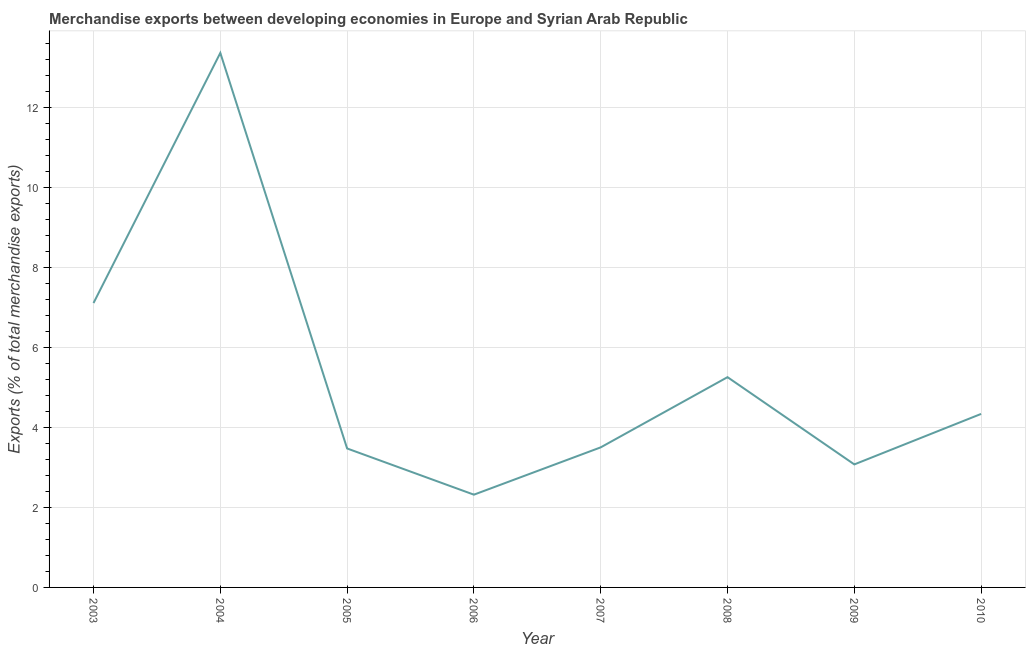What is the merchandise exports in 2007?
Your answer should be very brief. 3.5. Across all years, what is the maximum merchandise exports?
Make the answer very short. 13.37. Across all years, what is the minimum merchandise exports?
Make the answer very short. 2.32. In which year was the merchandise exports maximum?
Ensure brevity in your answer.  2004. In which year was the merchandise exports minimum?
Your response must be concise. 2006. What is the sum of the merchandise exports?
Your answer should be compact. 42.46. What is the difference between the merchandise exports in 2003 and 2008?
Provide a short and direct response. 1.85. What is the average merchandise exports per year?
Provide a short and direct response. 5.31. What is the median merchandise exports?
Offer a terse response. 3.92. Do a majority of the years between 2009 and 2008 (inclusive) have merchandise exports greater than 2 %?
Make the answer very short. No. What is the ratio of the merchandise exports in 2003 to that in 2004?
Make the answer very short. 0.53. Is the merchandise exports in 2003 less than that in 2005?
Ensure brevity in your answer.  No. What is the difference between the highest and the second highest merchandise exports?
Give a very brief answer. 6.26. What is the difference between the highest and the lowest merchandise exports?
Keep it short and to the point. 11.05. In how many years, is the merchandise exports greater than the average merchandise exports taken over all years?
Your response must be concise. 2. Does the merchandise exports monotonically increase over the years?
Make the answer very short. No. How many lines are there?
Make the answer very short. 1. What is the difference between two consecutive major ticks on the Y-axis?
Make the answer very short. 2. Are the values on the major ticks of Y-axis written in scientific E-notation?
Ensure brevity in your answer.  No. Does the graph contain any zero values?
Make the answer very short. No. What is the title of the graph?
Make the answer very short. Merchandise exports between developing economies in Europe and Syrian Arab Republic. What is the label or title of the X-axis?
Your answer should be compact. Year. What is the label or title of the Y-axis?
Your response must be concise. Exports (% of total merchandise exports). What is the Exports (% of total merchandise exports) in 2003?
Your answer should be compact. 7.11. What is the Exports (% of total merchandise exports) of 2004?
Ensure brevity in your answer.  13.37. What is the Exports (% of total merchandise exports) in 2005?
Offer a terse response. 3.48. What is the Exports (% of total merchandise exports) of 2006?
Your response must be concise. 2.32. What is the Exports (% of total merchandise exports) of 2007?
Offer a terse response. 3.5. What is the Exports (% of total merchandise exports) in 2008?
Provide a succinct answer. 5.26. What is the Exports (% of total merchandise exports) in 2009?
Your answer should be very brief. 3.08. What is the Exports (% of total merchandise exports) of 2010?
Your response must be concise. 4.34. What is the difference between the Exports (% of total merchandise exports) in 2003 and 2004?
Your answer should be compact. -6.26. What is the difference between the Exports (% of total merchandise exports) in 2003 and 2005?
Provide a succinct answer. 3.64. What is the difference between the Exports (% of total merchandise exports) in 2003 and 2006?
Your response must be concise. 4.79. What is the difference between the Exports (% of total merchandise exports) in 2003 and 2007?
Provide a succinct answer. 3.61. What is the difference between the Exports (% of total merchandise exports) in 2003 and 2008?
Your answer should be compact. 1.85. What is the difference between the Exports (% of total merchandise exports) in 2003 and 2009?
Provide a short and direct response. 4.04. What is the difference between the Exports (% of total merchandise exports) in 2003 and 2010?
Give a very brief answer. 2.77. What is the difference between the Exports (% of total merchandise exports) in 2004 and 2005?
Offer a terse response. 9.89. What is the difference between the Exports (% of total merchandise exports) in 2004 and 2006?
Offer a terse response. 11.05. What is the difference between the Exports (% of total merchandise exports) in 2004 and 2007?
Keep it short and to the point. 9.87. What is the difference between the Exports (% of total merchandise exports) in 2004 and 2008?
Ensure brevity in your answer.  8.11. What is the difference between the Exports (% of total merchandise exports) in 2004 and 2009?
Provide a succinct answer. 10.29. What is the difference between the Exports (% of total merchandise exports) in 2004 and 2010?
Make the answer very short. 9.03. What is the difference between the Exports (% of total merchandise exports) in 2005 and 2006?
Your answer should be very brief. 1.16. What is the difference between the Exports (% of total merchandise exports) in 2005 and 2007?
Offer a terse response. -0.03. What is the difference between the Exports (% of total merchandise exports) in 2005 and 2008?
Offer a very short reply. -1.78. What is the difference between the Exports (% of total merchandise exports) in 2005 and 2009?
Provide a succinct answer. 0.4. What is the difference between the Exports (% of total merchandise exports) in 2005 and 2010?
Give a very brief answer. -0.86. What is the difference between the Exports (% of total merchandise exports) in 2006 and 2007?
Your answer should be compact. -1.18. What is the difference between the Exports (% of total merchandise exports) in 2006 and 2008?
Offer a terse response. -2.94. What is the difference between the Exports (% of total merchandise exports) in 2006 and 2009?
Keep it short and to the point. -0.76. What is the difference between the Exports (% of total merchandise exports) in 2006 and 2010?
Make the answer very short. -2.02. What is the difference between the Exports (% of total merchandise exports) in 2007 and 2008?
Make the answer very short. -1.76. What is the difference between the Exports (% of total merchandise exports) in 2007 and 2009?
Your response must be concise. 0.43. What is the difference between the Exports (% of total merchandise exports) in 2007 and 2010?
Ensure brevity in your answer.  -0.84. What is the difference between the Exports (% of total merchandise exports) in 2008 and 2009?
Give a very brief answer. 2.18. What is the difference between the Exports (% of total merchandise exports) in 2008 and 2010?
Your answer should be compact. 0.92. What is the difference between the Exports (% of total merchandise exports) in 2009 and 2010?
Your response must be concise. -1.26. What is the ratio of the Exports (% of total merchandise exports) in 2003 to that in 2004?
Your answer should be very brief. 0.53. What is the ratio of the Exports (% of total merchandise exports) in 2003 to that in 2005?
Offer a terse response. 2.05. What is the ratio of the Exports (% of total merchandise exports) in 2003 to that in 2006?
Ensure brevity in your answer.  3.07. What is the ratio of the Exports (% of total merchandise exports) in 2003 to that in 2007?
Make the answer very short. 2.03. What is the ratio of the Exports (% of total merchandise exports) in 2003 to that in 2008?
Your answer should be compact. 1.35. What is the ratio of the Exports (% of total merchandise exports) in 2003 to that in 2009?
Ensure brevity in your answer.  2.31. What is the ratio of the Exports (% of total merchandise exports) in 2003 to that in 2010?
Your answer should be compact. 1.64. What is the ratio of the Exports (% of total merchandise exports) in 2004 to that in 2005?
Provide a short and direct response. 3.85. What is the ratio of the Exports (% of total merchandise exports) in 2004 to that in 2006?
Provide a short and direct response. 5.76. What is the ratio of the Exports (% of total merchandise exports) in 2004 to that in 2007?
Provide a succinct answer. 3.82. What is the ratio of the Exports (% of total merchandise exports) in 2004 to that in 2008?
Ensure brevity in your answer.  2.54. What is the ratio of the Exports (% of total merchandise exports) in 2004 to that in 2009?
Your answer should be very brief. 4.34. What is the ratio of the Exports (% of total merchandise exports) in 2004 to that in 2010?
Your response must be concise. 3.08. What is the ratio of the Exports (% of total merchandise exports) in 2005 to that in 2006?
Offer a very short reply. 1.5. What is the ratio of the Exports (% of total merchandise exports) in 2005 to that in 2008?
Provide a short and direct response. 0.66. What is the ratio of the Exports (% of total merchandise exports) in 2005 to that in 2009?
Ensure brevity in your answer.  1.13. What is the ratio of the Exports (% of total merchandise exports) in 2005 to that in 2010?
Provide a short and direct response. 0.8. What is the ratio of the Exports (% of total merchandise exports) in 2006 to that in 2007?
Your answer should be compact. 0.66. What is the ratio of the Exports (% of total merchandise exports) in 2006 to that in 2008?
Offer a very short reply. 0.44. What is the ratio of the Exports (% of total merchandise exports) in 2006 to that in 2009?
Your response must be concise. 0.75. What is the ratio of the Exports (% of total merchandise exports) in 2006 to that in 2010?
Offer a terse response. 0.54. What is the ratio of the Exports (% of total merchandise exports) in 2007 to that in 2008?
Offer a terse response. 0.67. What is the ratio of the Exports (% of total merchandise exports) in 2007 to that in 2009?
Provide a succinct answer. 1.14. What is the ratio of the Exports (% of total merchandise exports) in 2007 to that in 2010?
Offer a terse response. 0.81. What is the ratio of the Exports (% of total merchandise exports) in 2008 to that in 2009?
Keep it short and to the point. 1.71. What is the ratio of the Exports (% of total merchandise exports) in 2008 to that in 2010?
Provide a short and direct response. 1.21. What is the ratio of the Exports (% of total merchandise exports) in 2009 to that in 2010?
Give a very brief answer. 0.71. 